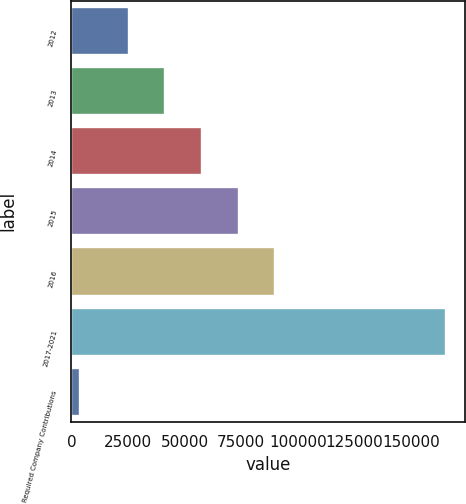Convert chart. <chart><loc_0><loc_0><loc_500><loc_500><bar_chart><fcel>2012<fcel>2013<fcel>2014<fcel>2015<fcel>2016<fcel>2017-2021<fcel>Required Company Contributions<nl><fcel>25378<fcel>41574.9<fcel>57771.8<fcel>73968.7<fcel>90165.6<fcel>165668<fcel>3699<nl></chart> 